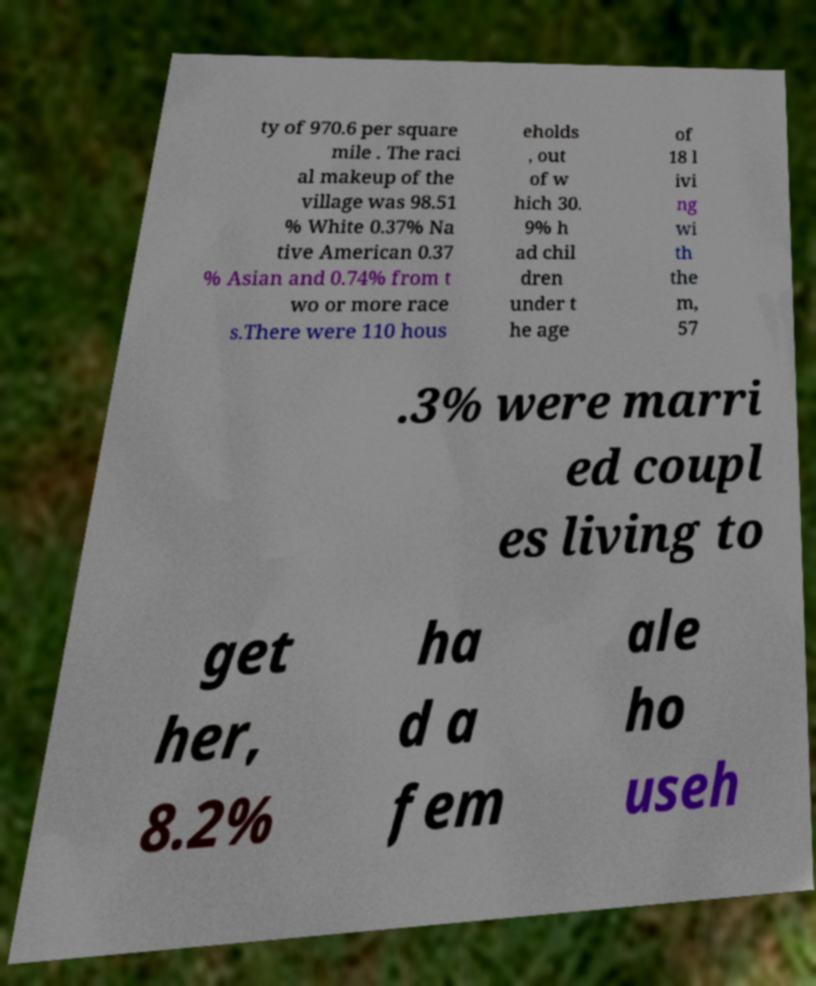Could you extract and type out the text from this image? ty of 970.6 per square mile . The raci al makeup of the village was 98.51 % White 0.37% Na tive American 0.37 % Asian and 0.74% from t wo or more race s.There were 110 hous eholds , out of w hich 30. 9% h ad chil dren under t he age of 18 l ivi ng wi th the m, 57 .3% were marri ed coupl es living to get her, 8.2% ha d a fem ale ho useh 